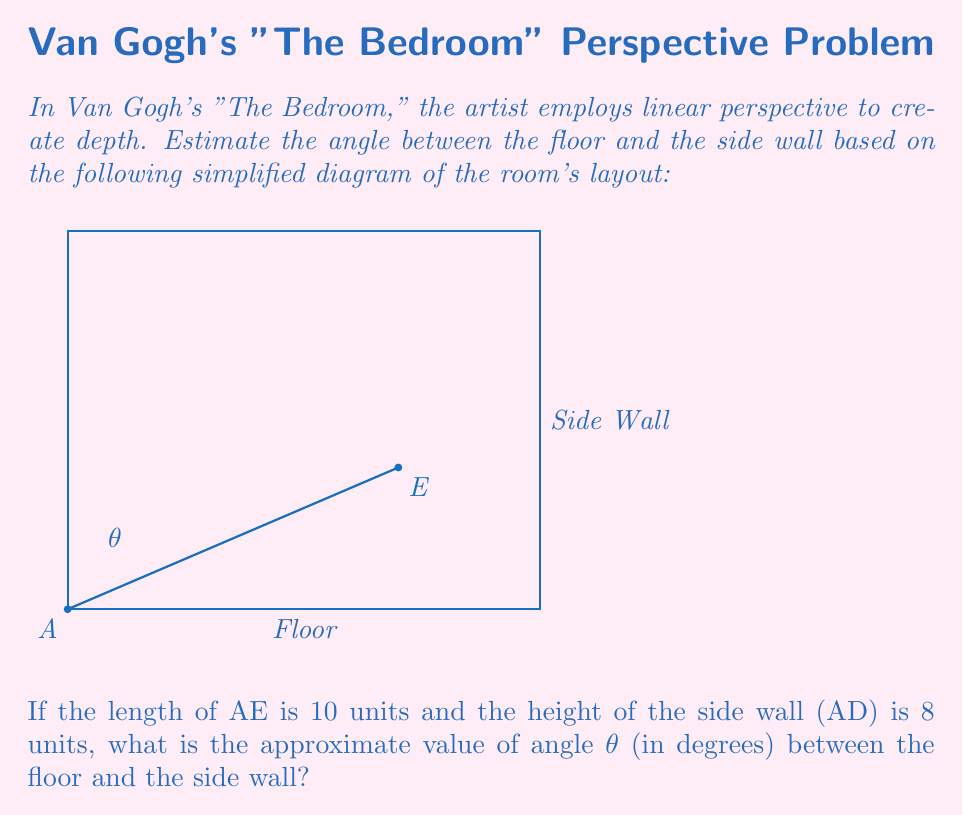Can you answer this question? To solve this problem, we'll use trigonometry, specifically the tangent function. Let's approach this step-by-step:

1) In the right triangle formed by AE and the side wall:
   - The opposite side is the height of the side wall (AD), which is 8 units.
   - The hypotenuse is AE, which is 10 units.

2) We can find the adjacent side using the Pythagorean theorem:
   $$(adjacent)^2 = AE^2 - AD^2$$
   $$(adjacent)^2 = 10^2 - 8^2 = 100 - 64 = 36$$
   $$adjacent = 6$$

3) Now we can use the tangent function to find the angle:
   $$\tan(\theta) = \frac{opposite}{adjacent} = \frac{8}{6}$$

4) To find θ, we need to use the inverse tangent (arctan or tan^(-1)):
   $$\theta = \tan^{-1}(\frac{8}{6})$$

5) Using a calculator or mathematical software:
   $$\theta \approx 53.13°$$

6) Rounding to the nearest degree:
   $$\theta \approx 53°$$

This angle represents the estimated perspective angle between the floor and the side wall in Van Gogh's "The Bedroom" based on the given simplified diagram.
Answer: $53°$ 